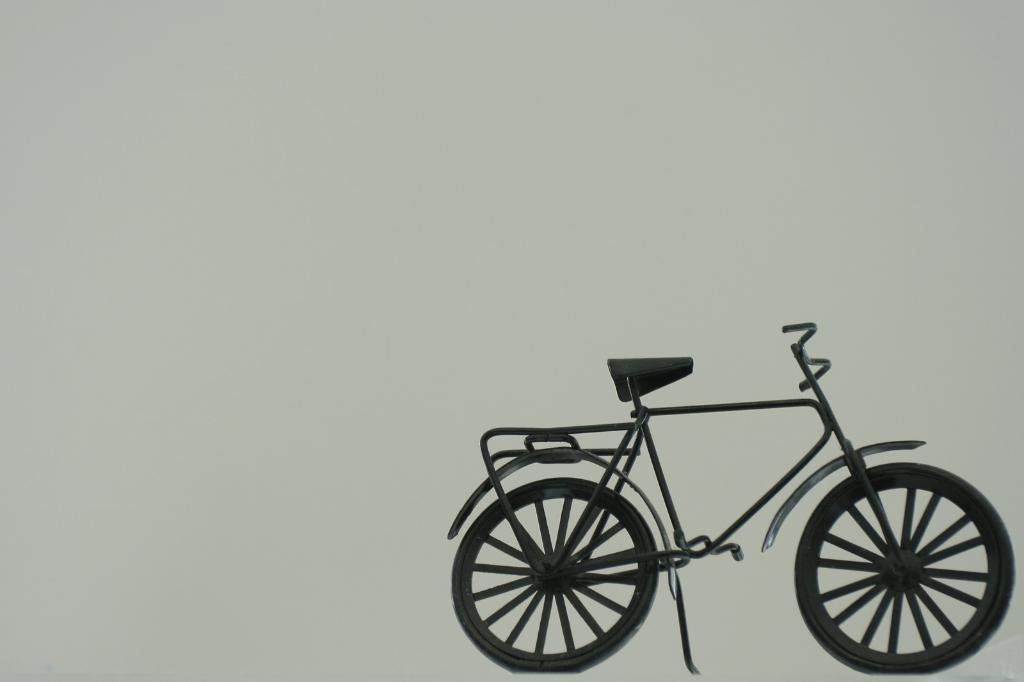What is the main object in the image? There is a bicycle in the image. What can be seen in the background of the image? The background of the image is white. How many straws are placed on the bicycle in the image? There are no straws present in the image; it features a bicycle against a white background. What type of watch can be seen on the bicycle in the image? There is no watch present on the bicycle in the image. 